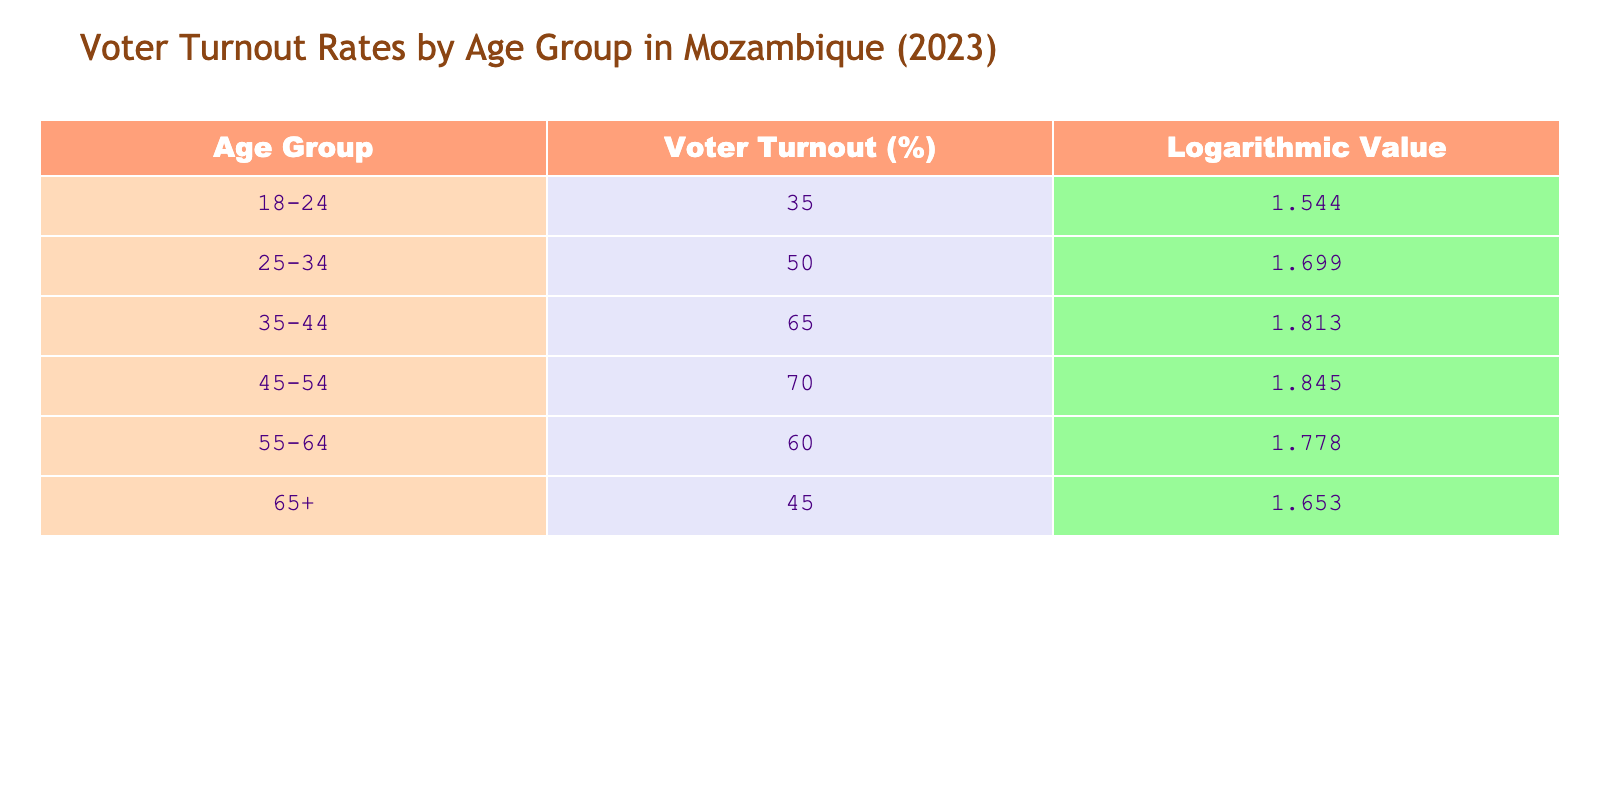What is the voter turnout percentage for the age group 25-34? In the table, we look for the row corresponding to the age group 25-34 and find the Voter Turnout value, which is 50%.
Answer: 50% What is the logarithmic value for the age group 45-54? The table shows that for the age group 45-54, the Logarithmic Value is listed as 1.845.
Answer: 1.845 Which age group has the lowest voter turnout percentage? By examining each row in the Voter Turnout column, we see that the age group 18-24 has a turnout of 35%, which is the lowest compared to the other age groups listed.
Answer: 18-24 What is the difference in voter turnout between the age groups 35-44 and 55-64? The voter turnout for 35-44 is 65%, and for 55-64 it is 60%. To find the difference, we subtract the latter from the former: 65 - 60 = 5.
Answer: 5% Is it true that the voter turnout for those aged 65 and above is higher than for those aged 18-24? The voter turnout for the 65 and over age group is 45%, while for the 18-24 age group it is 35%. Since 45 is greater than 35, the statement is true.
Answer: Yes What is the average voter turnout across all age groups represented in the table? First, we sum the voter turnout percentages: 35 + 50 + 65 + 70 + 60 + 45 = 325. There are 6 age groups, so we divide 325 by 6 to find the average: 325 / 6 ≈ 54.17.
Answer: 54.17 Which age group has the highest logarithmic value, and what is that value? We review the Logarithmic Value for each age group; 1.845 for 45-54 is the highest value listed, making it the highest logarithmic value.
Answer: 45-54, 1.845 If the voter turnout for the age group 55-64 were to increase by 10%, what would the new voter turnout be? The current voter turnout for 55-64 is 60%. A 10% increase means we calculate: 60 + (10% of 60) = 60 + 6 = 66.
Answer: 66% What is the cumulative voter turnout percentage for age groups below 45? We add the voter turnout percentages of the age groups 18-24, 25-34, and 35-44: 35 + 50 + 65 = 150.
Answer: 150 